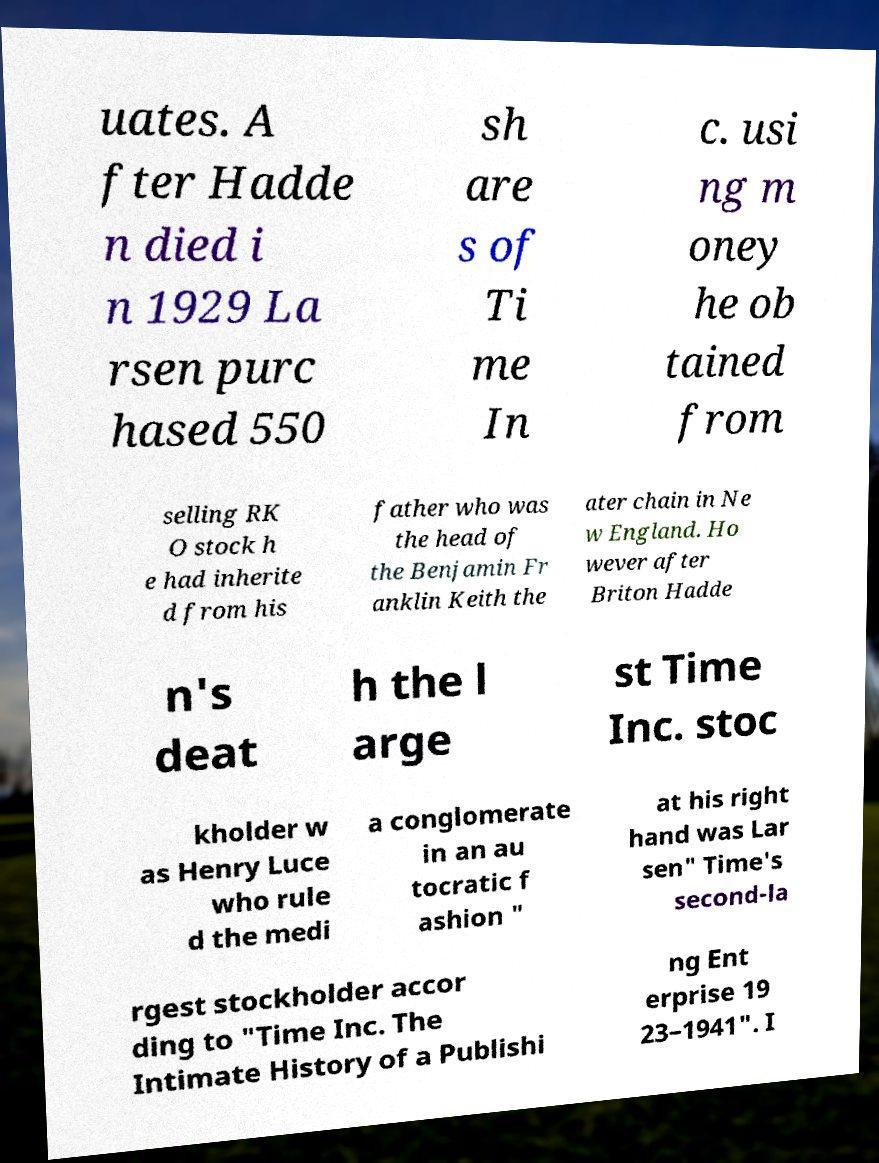Please identify and transcribe the text found in this image. uates. A fter Hadde n died i n 1929 La rsen purc hased 550 sh are s of Ti me In c. usi ng m oney he ob tained from selling RK O stock h e had inherite d from his father who was the head of the Benjamin Fr anklin Keith the ater chain in Ne w England. Ho wever after Briton Hadde n's deat h the l arge st Time Inc. stoc kholder w as Henry Luce who rule d the medi a conglomerate in an au tocratic f ashion " at his right hand was Lar sen" Time's second-la rgest stockholder accor ding to "Time Inc. The Intimate History of a Publishi ng Ent erprise 19 23–1941". I 